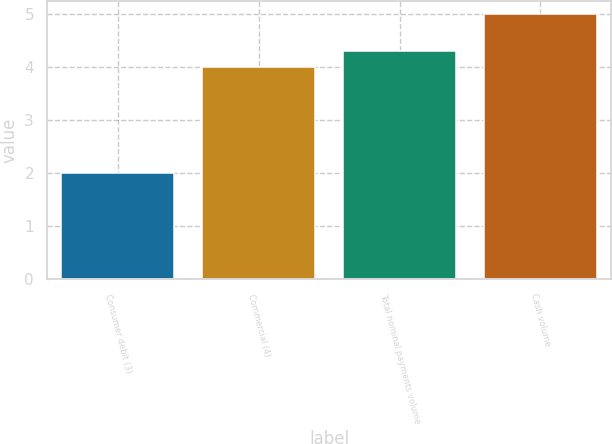<chart> <loc_0><loc_0><loc_500><loc_500><bar_chart><fcel>Consumer debit (3)<fcel>Commercial (4)<fcel>Total nominal payments volume<fcel>Cash volume<nl><fcel>2<fcel>4<fcel>4.3<fcel>5<nl></chart> 